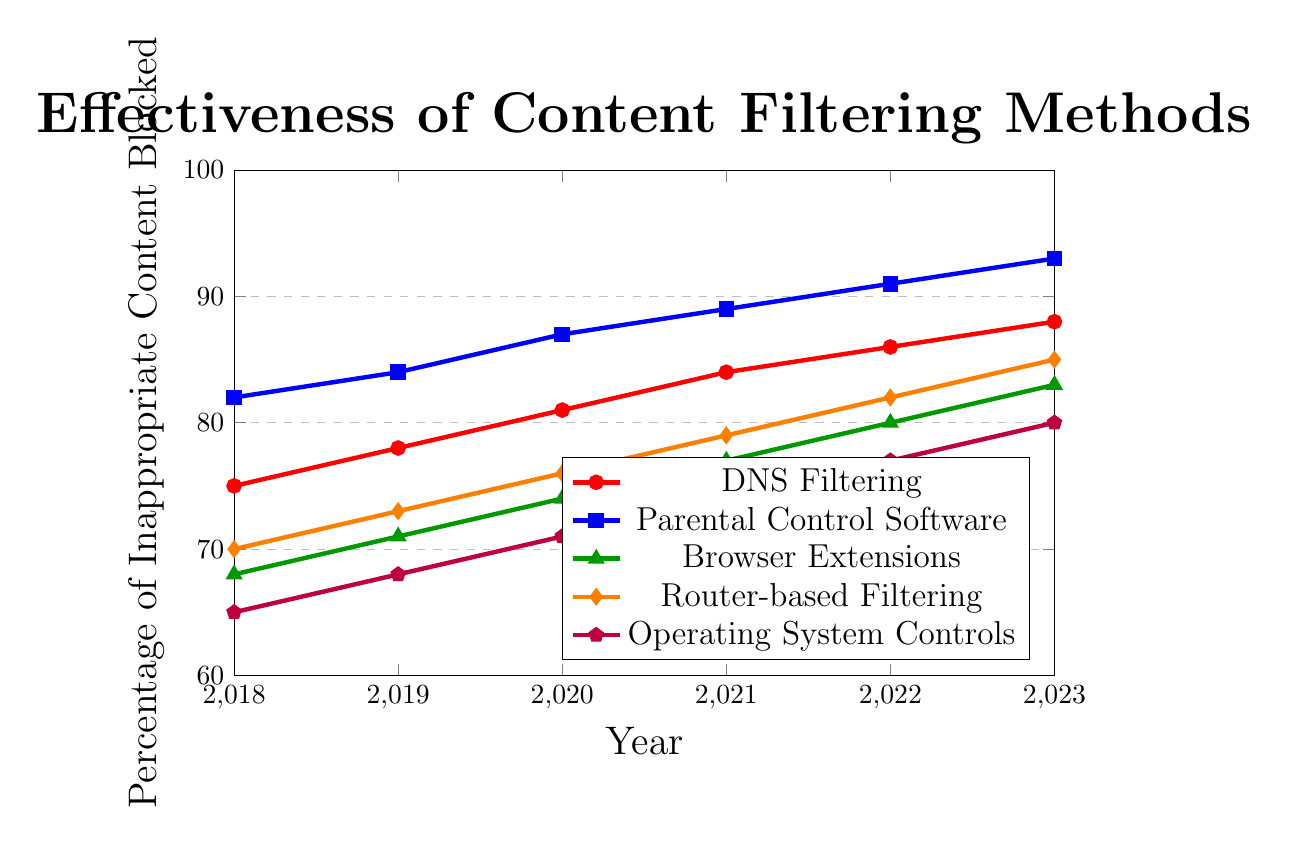Which content filtering method showed the greatest improvement from 2018 to 2023? To determine this, subtract the 2018 value from the 2023 value for each method. The method with the largest difference has the greatest improvement. DNS Filtering: 88-75=13, Parental Control Software: 93-82=11, Browser Extensions: 83-68=15, Router-based Filtering: 85-70=15, Operating System Controls: 80-65=15. Browser Extensions, Router-based Filtering, and Operating System Controls all improve by 15.
Answer: Browser Extensions, Router-based Filtering, Operating System Controls In what year did Parental Control Software reach over 90% effectiveness? Check the data for Parental Control Software and identify the first year where the percentage exceeds 90%. This occurs in 2022.
Answer: 2022 Which method was the least effective in 2018? Look at the 2018 values for each method and identify the smallest value. Operating System Controls had the lowest percentage of inappropriate content blocked at 65%.
Answer: Operating System Controls What is the average effectiveness of Router-based Filtering over the six years shown? Sum the percentages for Router-based Filtering from 2018 to 2023 and divide by the number of years. (70+73+76+79+82+85)/6 = 77.5
Answer: 77.5 How does the effectiveness of Browser Extensions in 2021 compare to DNS Filtering in 2023? Compare the percentage values: Browser Extensions (77) in 2021 to DNS Filtering (88) in 2023. Since 77 < 88, DNS Filtering in 2023 is more effective.
Answer: DNS Filtering in 2023 is more effective Which two methods had the same percentage improvement over the years 2019 to 2020? Calculate the improvement for each method from 2019 to 2020 and find the ones with the same increase: DNS Filtering (81-78=3), Parental Control Software (87-84=3), Browser Extensions (74-71=3), Router-based Filtering (76-73=3), Operating System Controls (71-68=3). All methods show the same improvement of 3%.
Answer: All methods What is the median effectiveness of Operating System Controls over the six years shown? List the values for Operating System Controls (65, 68, 71, 74, 77, 80) and find the median, which is the middle value. For an even number of entries, the median is the average of the two middle values: (71+74)/2 = 72.5
Answer: 72.5 Which method showed the smallest change in effectiveness from 2022 to 2023? Calculate the change for each method from 2022 to 2023. The method with the smallest difference has the smallest change: DNS Filtering (88-86=2), Parental Control Software (93-91=2), Browser Extensions (83-80=3), Router-based Filtering (85-82=3), Operating System Controls (80-77=3). DNS Filtering and Parental Control Software have the smallest change with 2%.
Answer: DNS Filtering, Parental Control Software 